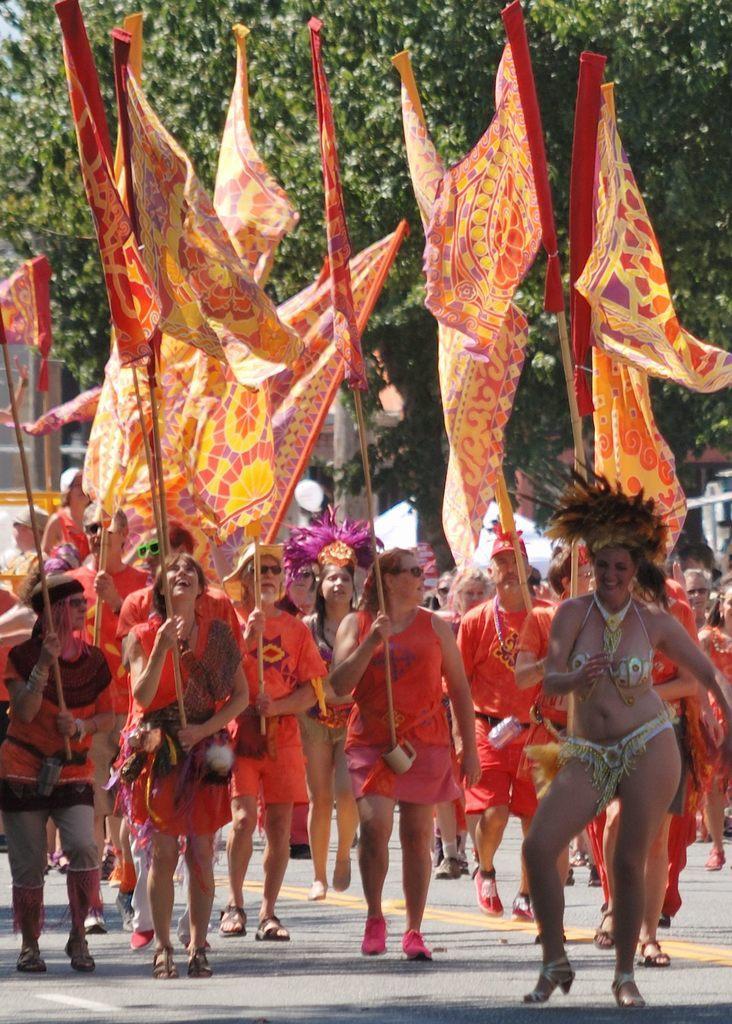How would you summarize this image in a sentence or two? In this image we can see a few people on the road, some of them are holding flags, there are some mugs, also we can see a tree. 